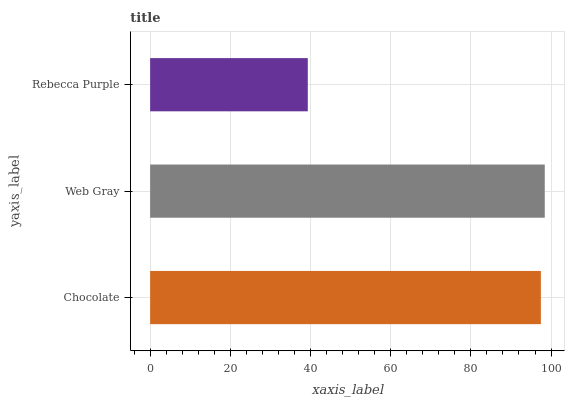Is Rebecca Purple the minimum?
Answer yes or no. Yes. Is Web Gray the maximum?
Answer yes or no. Yes. Is Web Gray the minimum?
Answer yes or no. No. Is Rebecca Purple the maximum?
Answer yes or no. No. Is Web Gray greater than Rebecca Purple?
Answer yes or no. Yes. Is Rebecca Purple less than Web Gray?
Answer yes or no. Yes. Is Rebecca Purple greater than Web Gray?
Answer yes or no. No. Is Web Gray less than Rebecca Purple?
Answer yes or no. No. Is Chocolate the high median?
Answer yes or no. Yes. Is Chocolate the low median?
Answer yes or no. Yes. Is Rebecca Purple the high median?
Answer yes or no. No. Is Web Gray the low median?
Answer yes or no. No. 